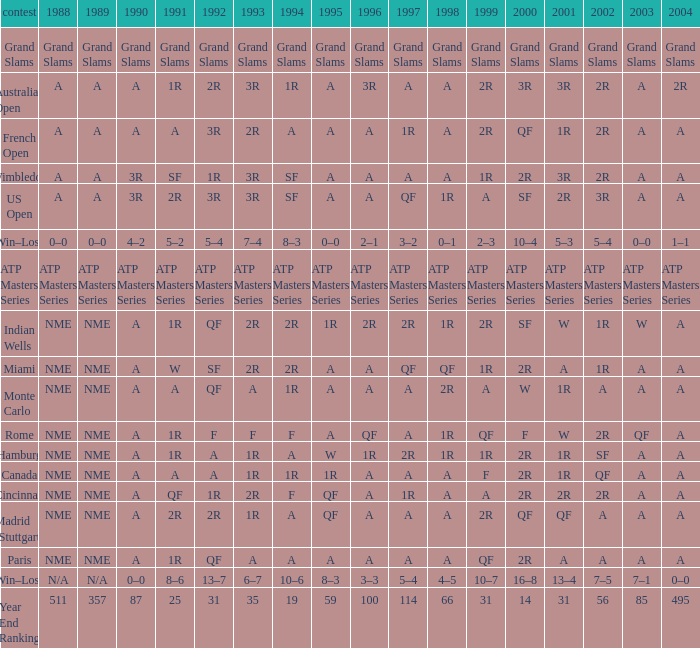What shows for 1995 when 1996 shows grand slams? Grand Slams. 